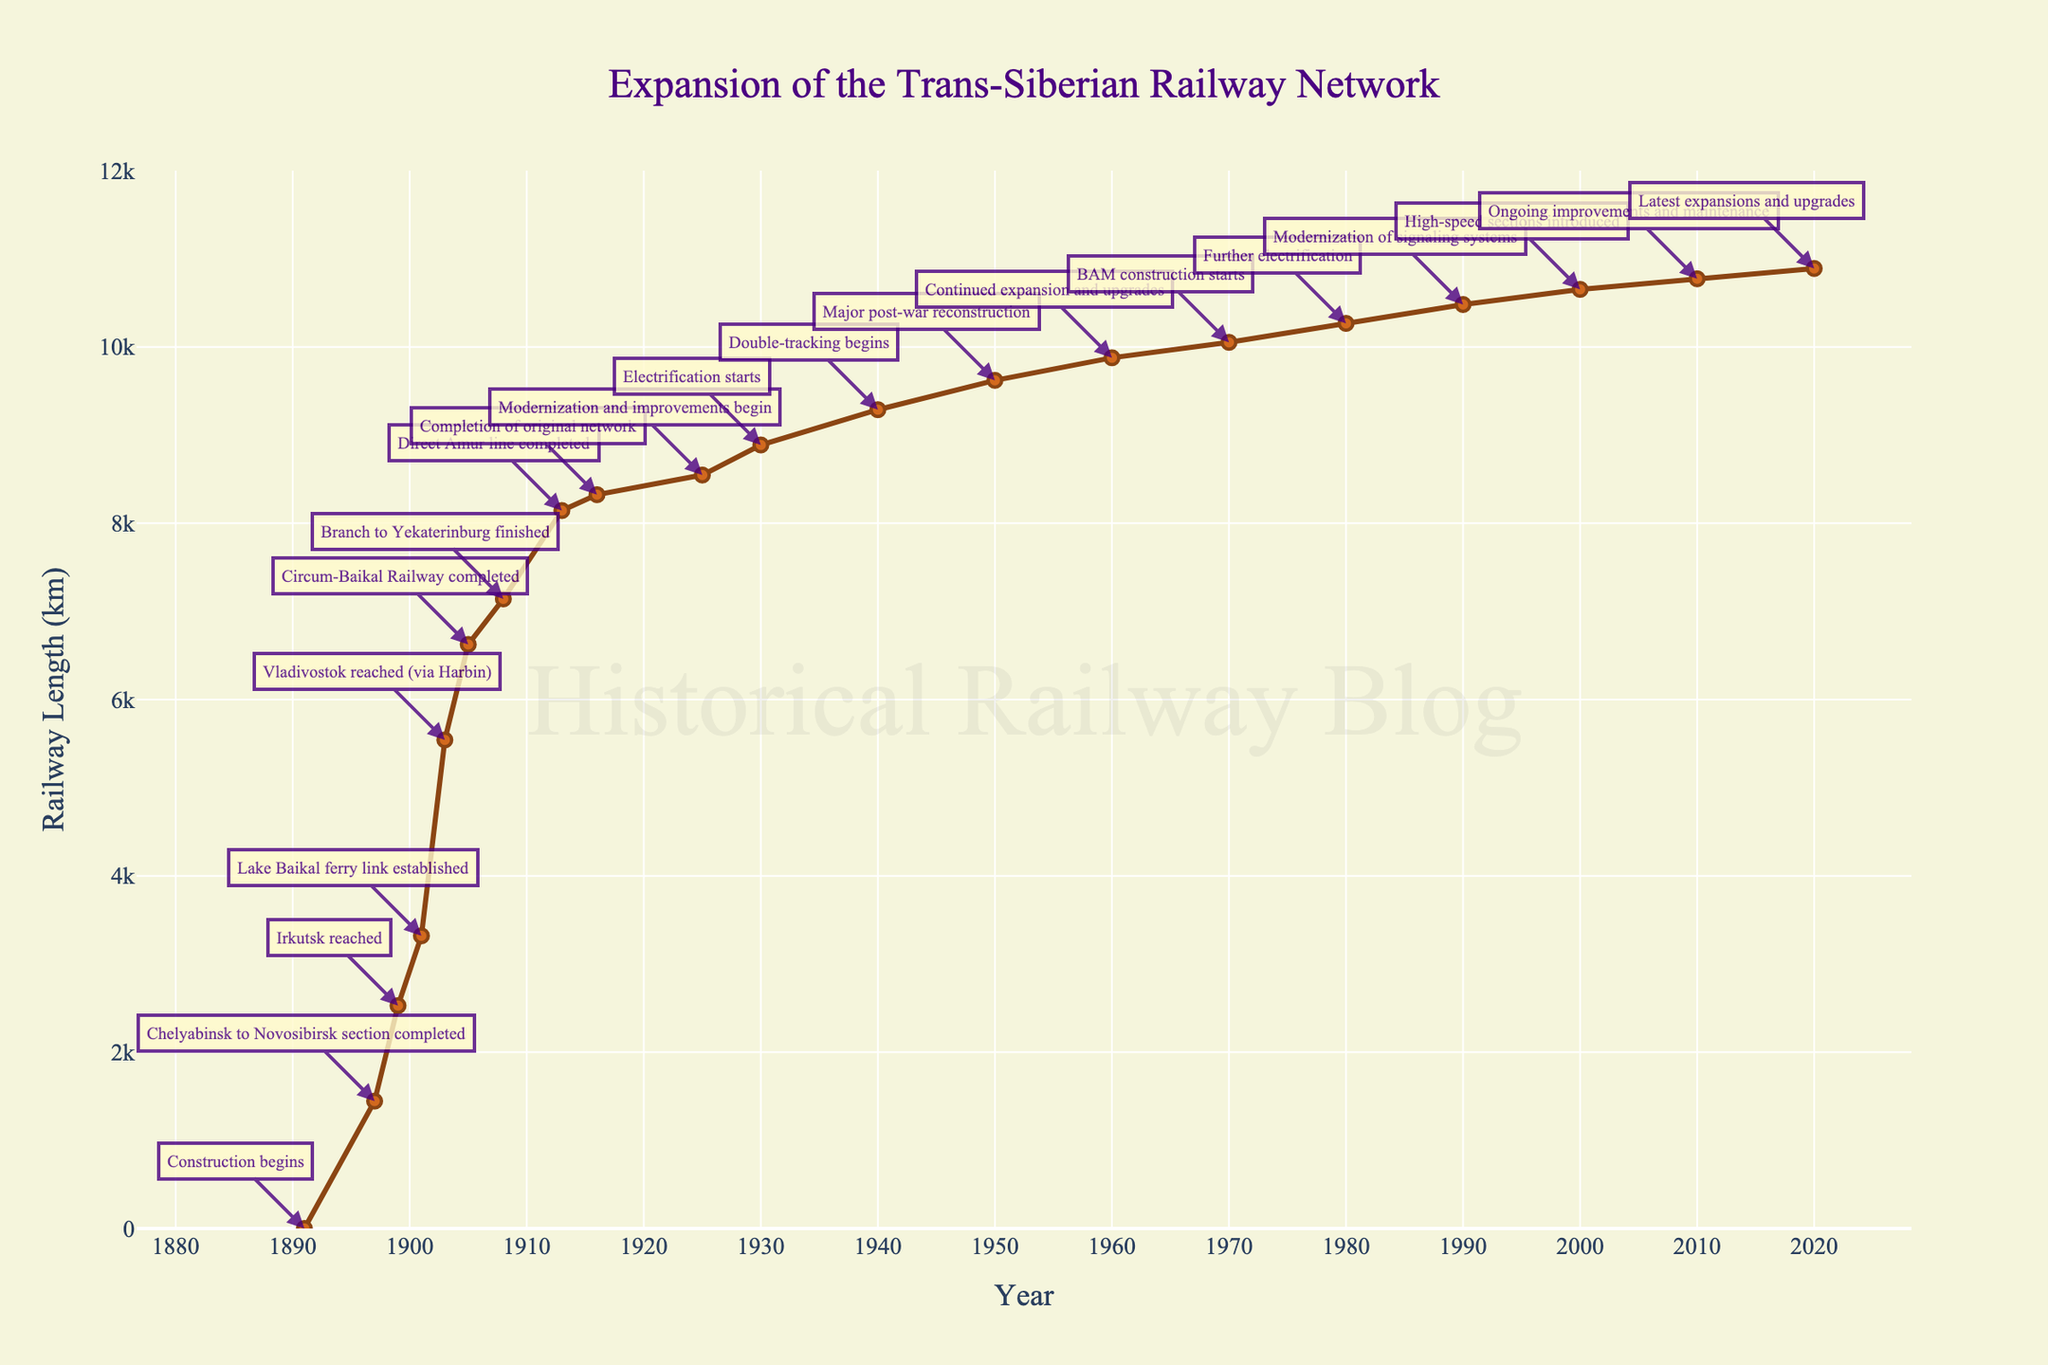What was the length of the Trans-Siberian Railway when the Lake Baikal ferry link was established? Identify the milestone "Lake Baikal ferry link established," which corresponds to the year 1901 and the railway length of 3320 km.
Answer: 3320 km When was the Vladivostok reached and what was its significance on the railway length? Identify the milestone "Vladivostok reached (via Harbin)," which corresponds to the year 1903, and note the railway length increase to 5542 km.
Answer: 1903, 5542 km Which year saw the largest single increase in railway length, and what were the before and after lengths? Compare the railway lengths at each milestone to find the largest difference. The largest increase happened from 1901 to 1903, with lengths changing from 3320 km to 5542 km (5542 - 3320 = 2222 km).
Answer: 1903, from 3320 km to 5542 km Between 1930 and 1950, how much did the railway length increase? Subtract the length in 1930 (8888 km) from the length in 1950 (9621 km) (9621 - 8888 = 733 km).
Answer: 733 km By how many kilometers did the railway length increase during the first decade after the end of World War II? Subtract the railway length in 1940 (9288 km) from that in 1950 (9621 km) (9621 - 9288 = 333 km).
Answer: 333 km What milestone was reached in 1916 and what was the associated length of railway? Identify the milestone "Completion of original network," which corresponds to the year 1916 and the railway length of 8324 km.
Answer: Completion of original network, 8324 km Compare the railway length in 1905 to the length in 1913 and find the difference. Subtract the railway length in 1905 (6625 km) from that in 1913 (8144 km) (8144 - 6625 = 1519 km).
Answer: 1519 km In which year did the railway reach the length of over 10,000 km, and what milestone occurred around this time? Identify the year where the length surpasses 10,000 km, which is 1970, and note the milestone "BAM construction starts."
Answer: 1970, BAM construction starts What can be inferred about the rate of expansion from 1891 to 2020 based on the figure? Examine the plot to see the changes in the slope of the line; rapid early growth, slowing down post-1925, and steady smaller increases post-1950.
Answer: Rapid early growth, slower expansion post-1925 How many significant milestones occurred between the years 1925 and 2020? Count the milestones listed in the dataset for the years in the specified range (1925, 1930, 1940, 1950, 1960, 1970, 1980, 1990, 2000, 2010, 2020).
Answer: 11 milestones 